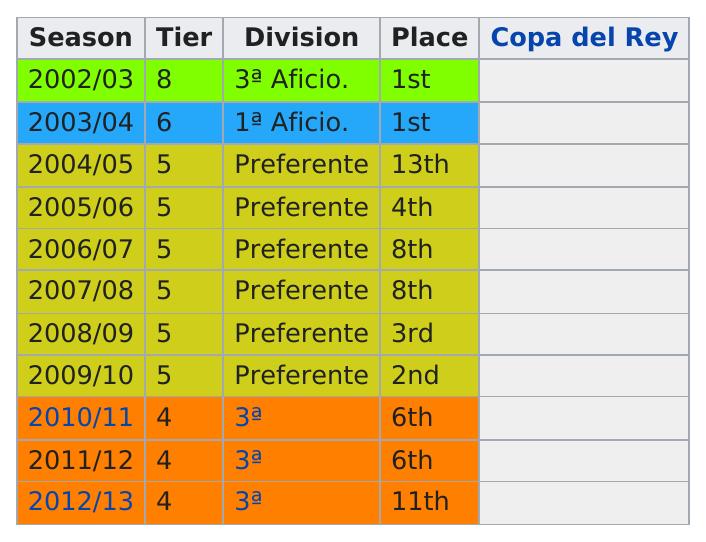Point out several critical features in this image. The team was in the third division for four years. Internacional de Madrid CF played in only one season of the 1ª División, which was the 2003/2004 season. The Preferente division has the largest number of ranks. The team achieved the same place as in 2010/11 in 2011/12. Internacional de Madrid C.F. has been playing in the 3ª division for 3 years. 